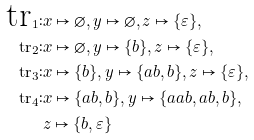Convert formula to latex. <formula><loc_0><loc_0><loc_500><loc_500>\text {tr} _ { 1 } \colon & x \mapsto \varnothing , y \mapsto \varnothing , z \mapsto \{ \varepsilon \} , \\ \text {tr} _ { 2 } \colon & x \mapsto \varnothing , y \mapsto \{ b \} , z \mapsto \{ \varepsilon \} , \\ \text {tr} _ { 3 } \colon & x \mapsto \{ b \} , y \mapsto \{ a b , b \} , z \mapsto \{ \varepsilon \} , \\ \text {tr} _ { 4 } \colon & x \mapsto \{ a b , b \} , y \mapsto \{ a a b , a b , b \} , \\ & z \mapsto \{ b , \varepsilon \}</formula> 